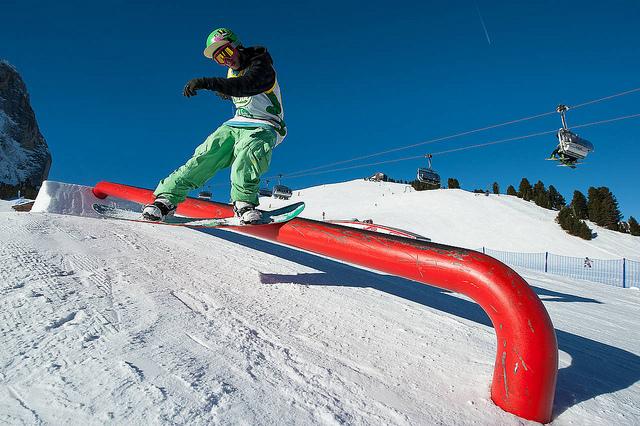Why is the ground white?
Write a very short answer. Snow. Is there a plane in the sky?
Concise answer only. No. What is this person standing on?
Answer briefly. Snowboard. 